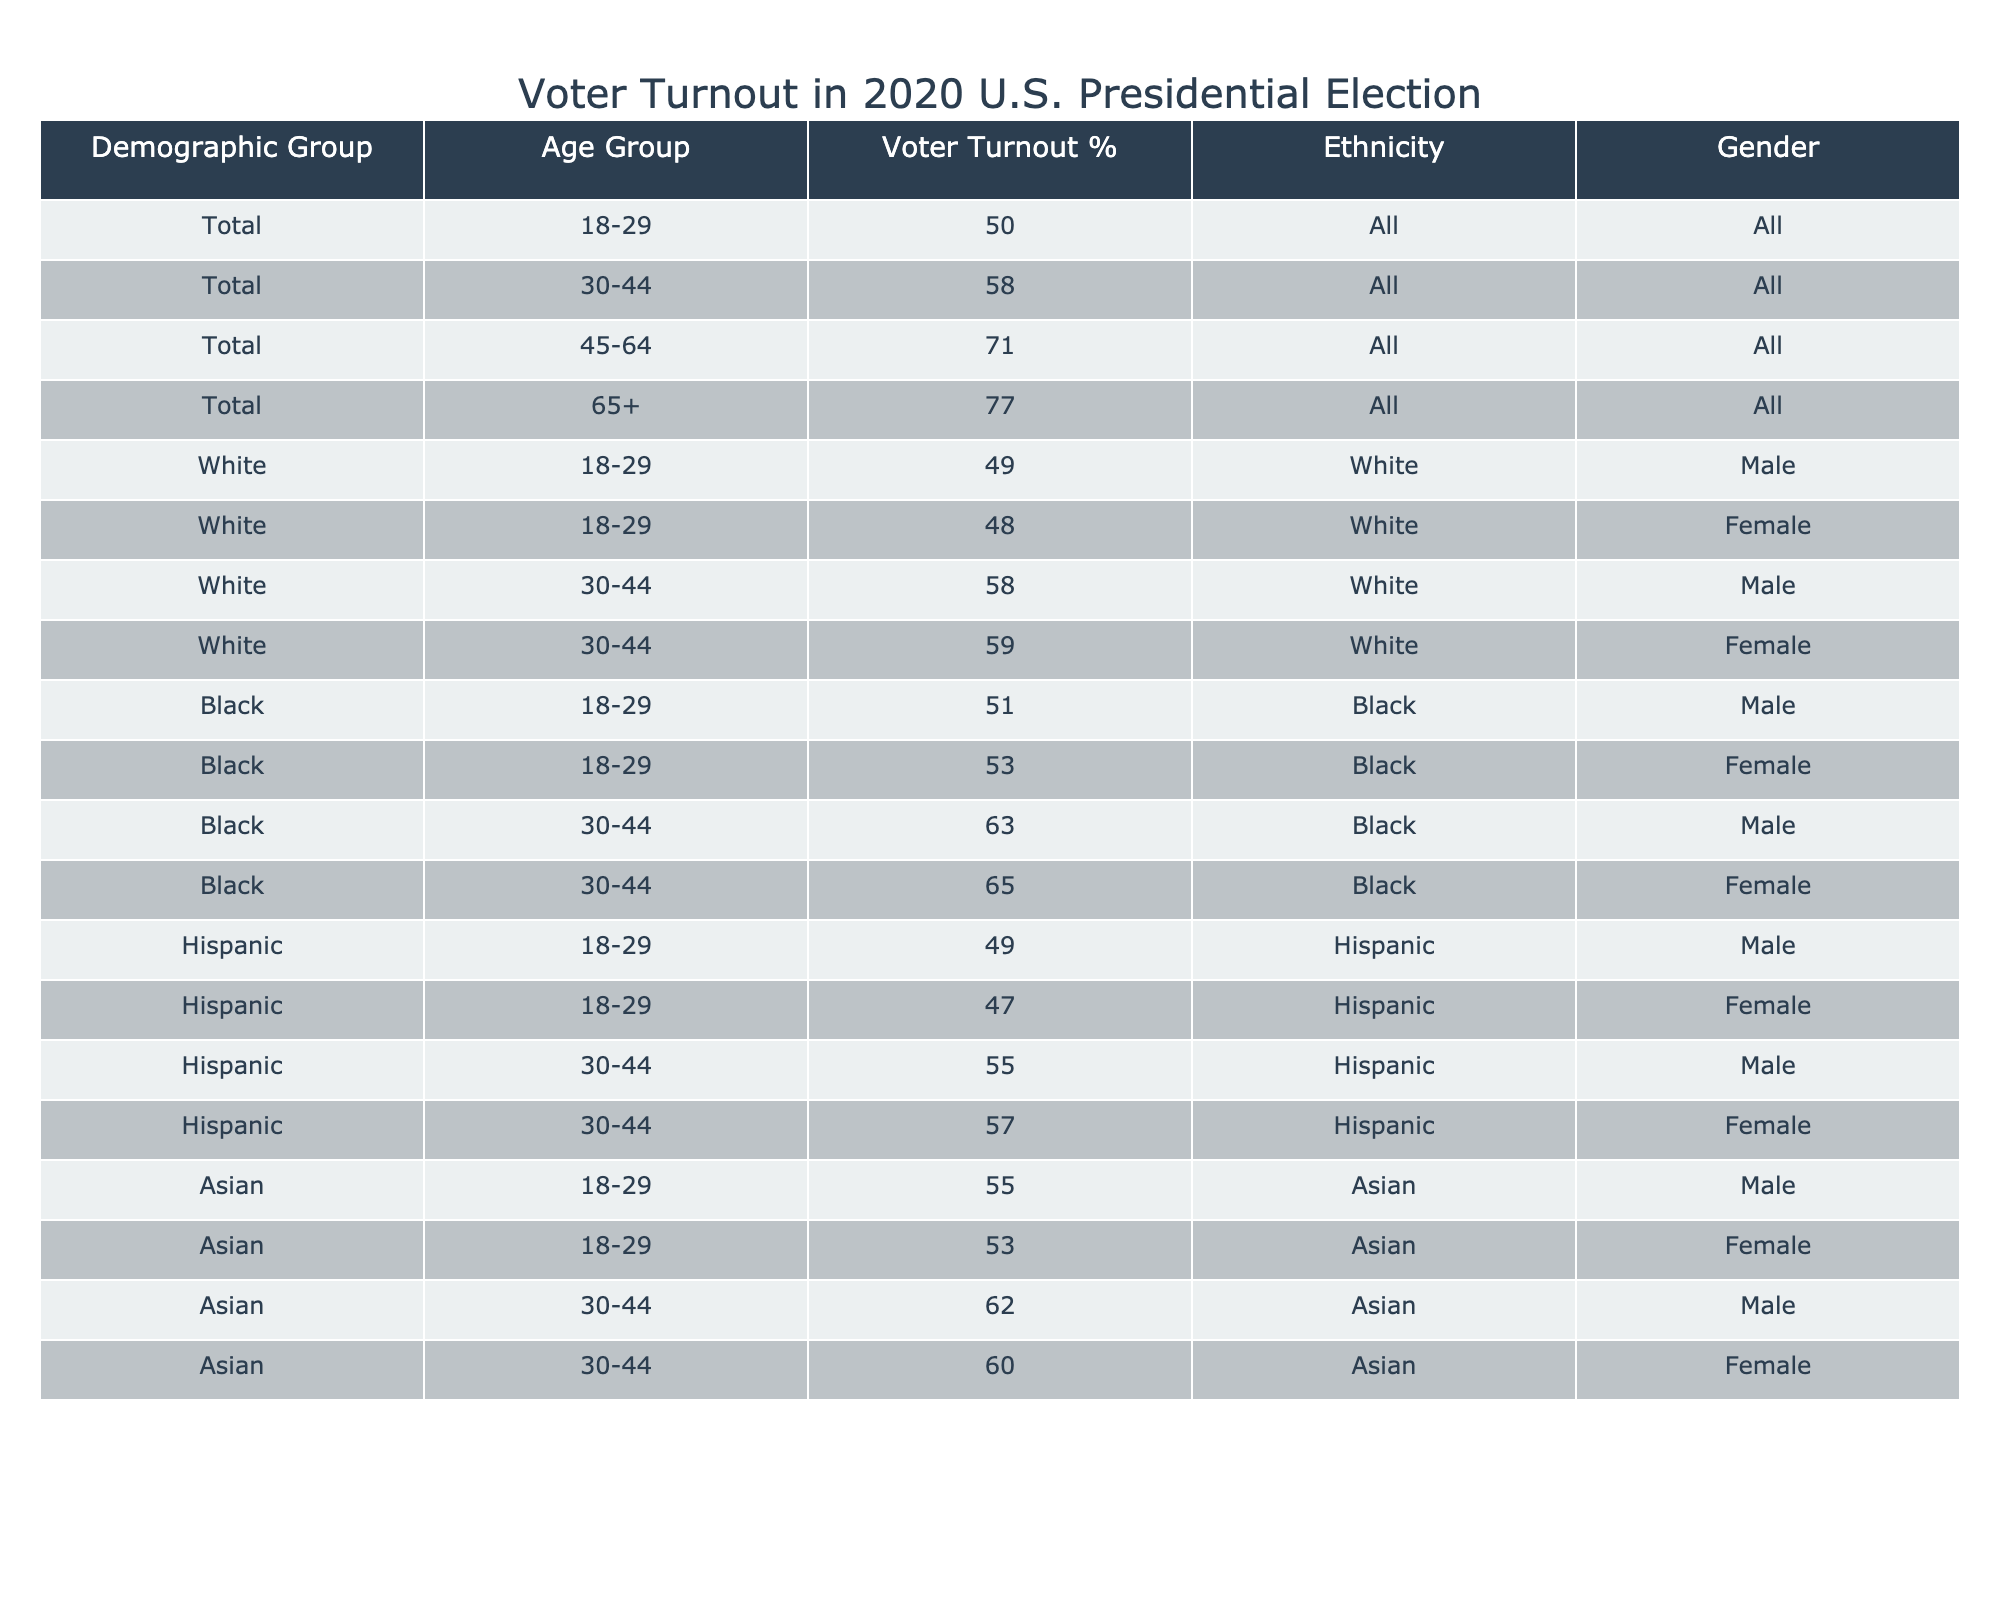What is the voter turnout percentage for the 18-29 age group across all demographics? The table shows that the voter turnout percentage for the 18-29 age group in the "Total" demographic is 50.0%.
Answer: 50.0% What is the voter turnout percentage for Hispanic females aged 30-44? According to the table, the voter turnout percentage for Hispanic females in the 30-44 age group is 57.0%.
Answer: 57.0% Is the voter turnout higher for the 45-64 age group compared to the 30-44 age group for Black females? The voter turnout for Black females aged 45-64 is not listed, but for the 30-44 age group, it's 65.0%. Without specific data for 45-64, this question cannot be answered with a yes or no.
Answer: No What is the difference in voter turnout percentage between Asian males aged 30-44 and White females aged 30-44? The voter turnout for Asian males aged 30-44 is 62.0%, and for White females in the same age group, it is 59.0%. The difference is 62.0% - 59.0% = 3.0%.
Answer: 3.0% Which demographic group has the highest overall voter turnout percentage in the age group 65 and older? The table provides that the overall turnout percentage for the 65+ age group is 77.0%, as listed in the "Total" demographic.
Answer: 77.0% What percentage of White females aged 18-29 compared to Black males aged 18-29 voted? White females aged 18-29 have a turnout of 48.0%, and Black males in the same age group turned out at 51.0%. Comparing these, Black males had a higher turnout by 3.0%.
Answer: 3.0% (more for Black males) Are the voter turnout percentages for Hispanic males and females in the 18-29 age group the same? The turnout for Hispanic males is 49.0%, while for females it is 47.0%, indicating they are not the same.
Answer: No What is the overall trend in voter turnout as age increases, based on the Total demographic? The table shows that as age increases (from 18-29 to 65+), the voter turnout percentages also increase (50.0%, 58.0%, 71.0%, 77.0%). This indicates a clear upward trend in voter turnout with age.
Answer: Yes How would you summarize the turnout percentages for all races in the 30-44 age group? The turnout percentages for each racial group in the 30-44 age group are 58.0% (White), 63.0% (Black), 55.0% (Hispanic), and 62.0% (Asian). The average turnout is (58.0% + 63.0% + 55.0% + 62.0%)/4 = 59.5%.
Answer: 59.5% 